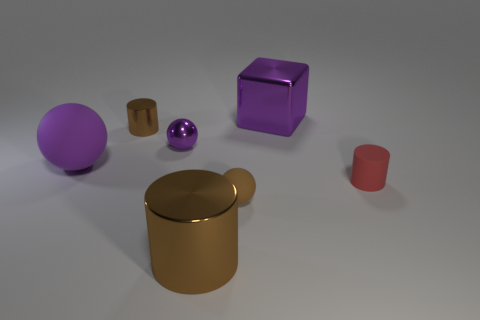Is the color of the big sphere the same as the small shiny sphere?
Ensure brevity in your answer.  Yes. There is a big purple thing that is on the right side of the small ball on the right side of the big thing that is in front of the big purple rubber object; what shape is it?
Your answer should be very brief. Cube. The brown matte sphere has what size?
Ensure brevity in your answer.  Small. There is a small cylinder that is made of the same material as the purple block; what is its color?
Ensure brevity in your answer.  Brown. What number of brown balls have the same material as the red thing?
Offer a very short reply. 1. There is a large metal block; is it the same color as the big object that is on the left side of the small purple shiny sphere?
Keep it short and to the point. Yes. There is a big matte ball that is behind the ball in front of the small red cylinder; what color is it?
Your answer should be compact. Purple. There is a matte cylinder that is the same size as the brown ball; what is its color?
Your answer should be very brief. Red. Are there any other small things that have the same shape as the tiny purple object?
Provide a succinct answer. Yes. What shape is the small brown matte thing?
Provide a succinct answer. Sphere. 